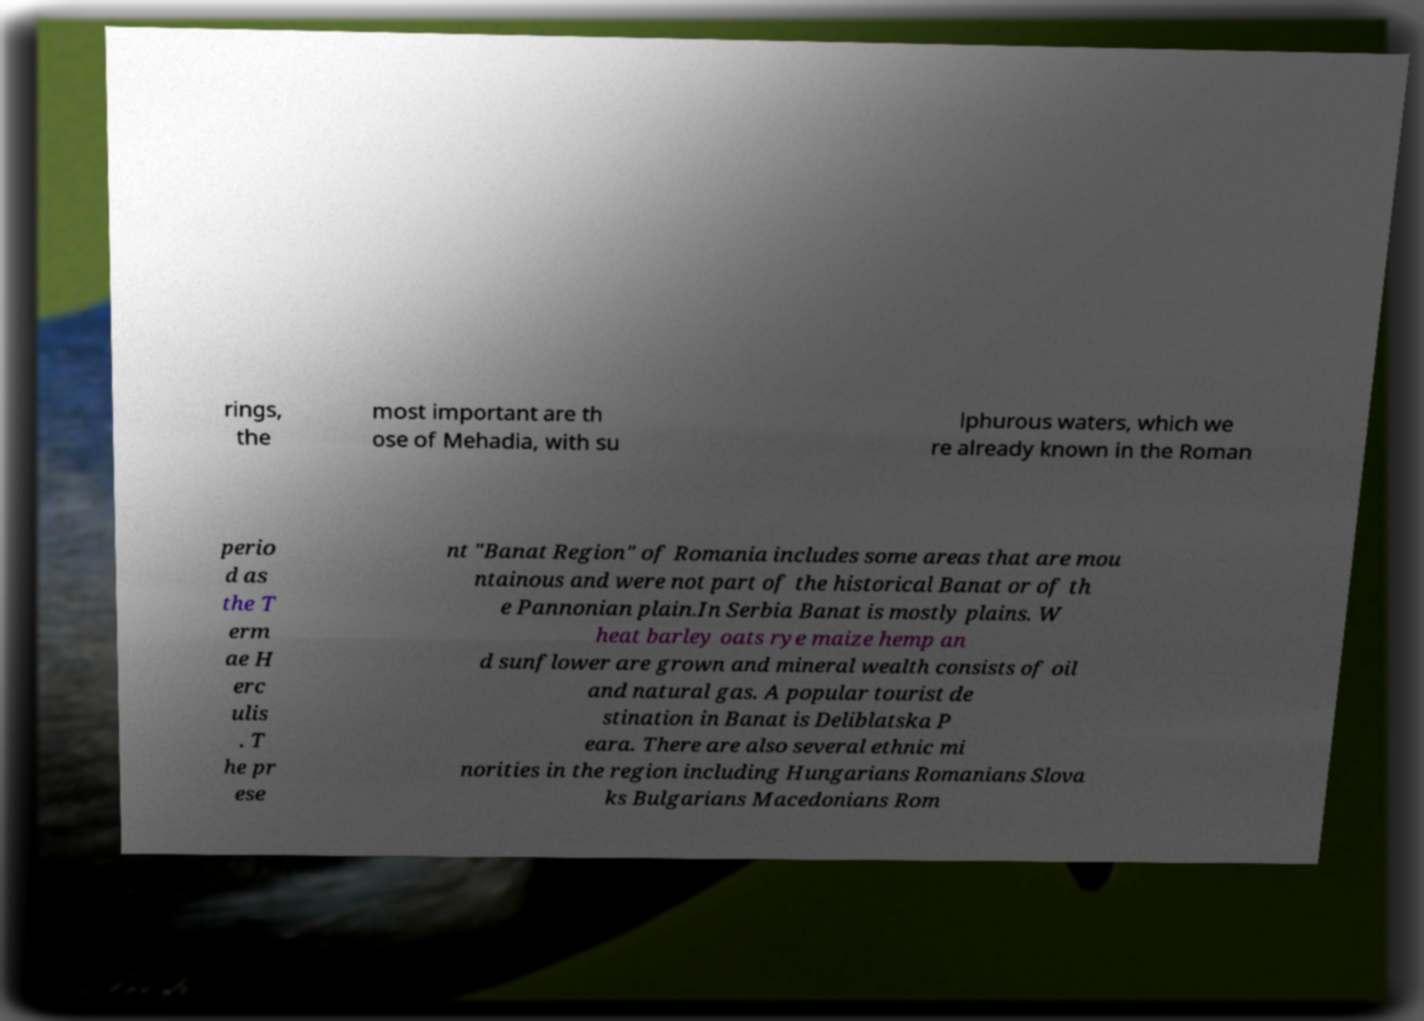Can you read and provide the text displayed in the image?This photo seems to have some interesting text. Can you extract and type it out for me? rings, the most important are th ose of Mehadia, with su lphurous waters, which we re already known in the Roman perio d as the T erm ae H erc ulis . T he pr ese nt "Banat Region" of Romania includes some areas that are mou ntainous and were not part of the historical Banat or of th e Pannonian plain.In Serbia Banat is mostly plains. W heat barley oats rye maize hemp an d sunflower are grown and mineral wealth consists of oil and natural gas. A popular tourist de stination in Banat is Deliblatska P eara. There are also several ethnic mi norities in the region including Hungarians Romanians Slova ks Bulgarians Macedonians Rom 